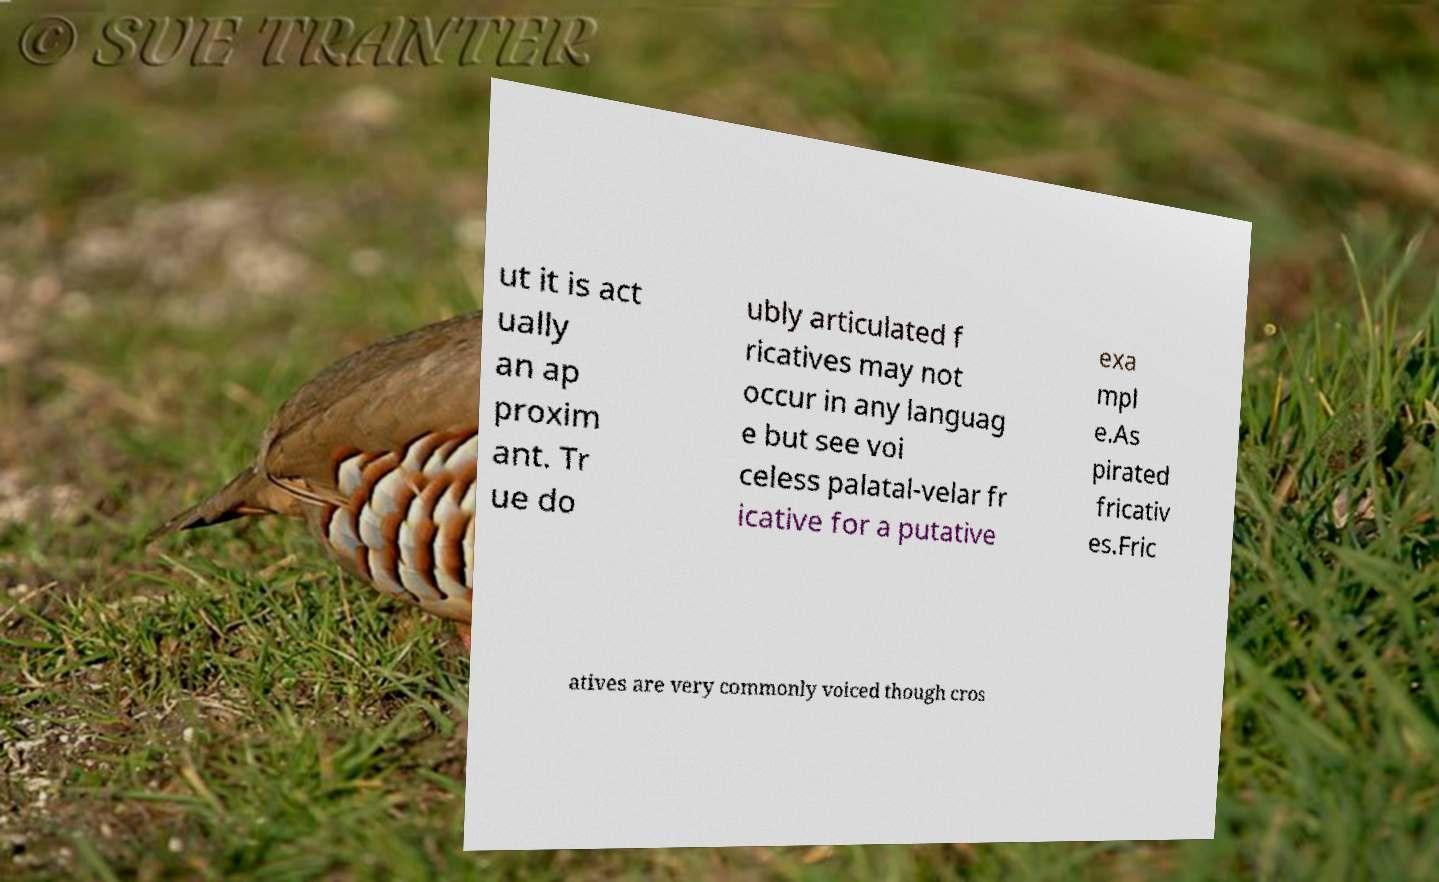Please identify and transcribe the text found in this image. ut it is act ually an ap proxim ant. Tr ue do ubly articulated f ricatives may not occur in any languag e but see voi celess palatal-velar fr icative for a putative exa mpl e.As pirated fricativ es.Fric atives are very commonly voiced though cros 